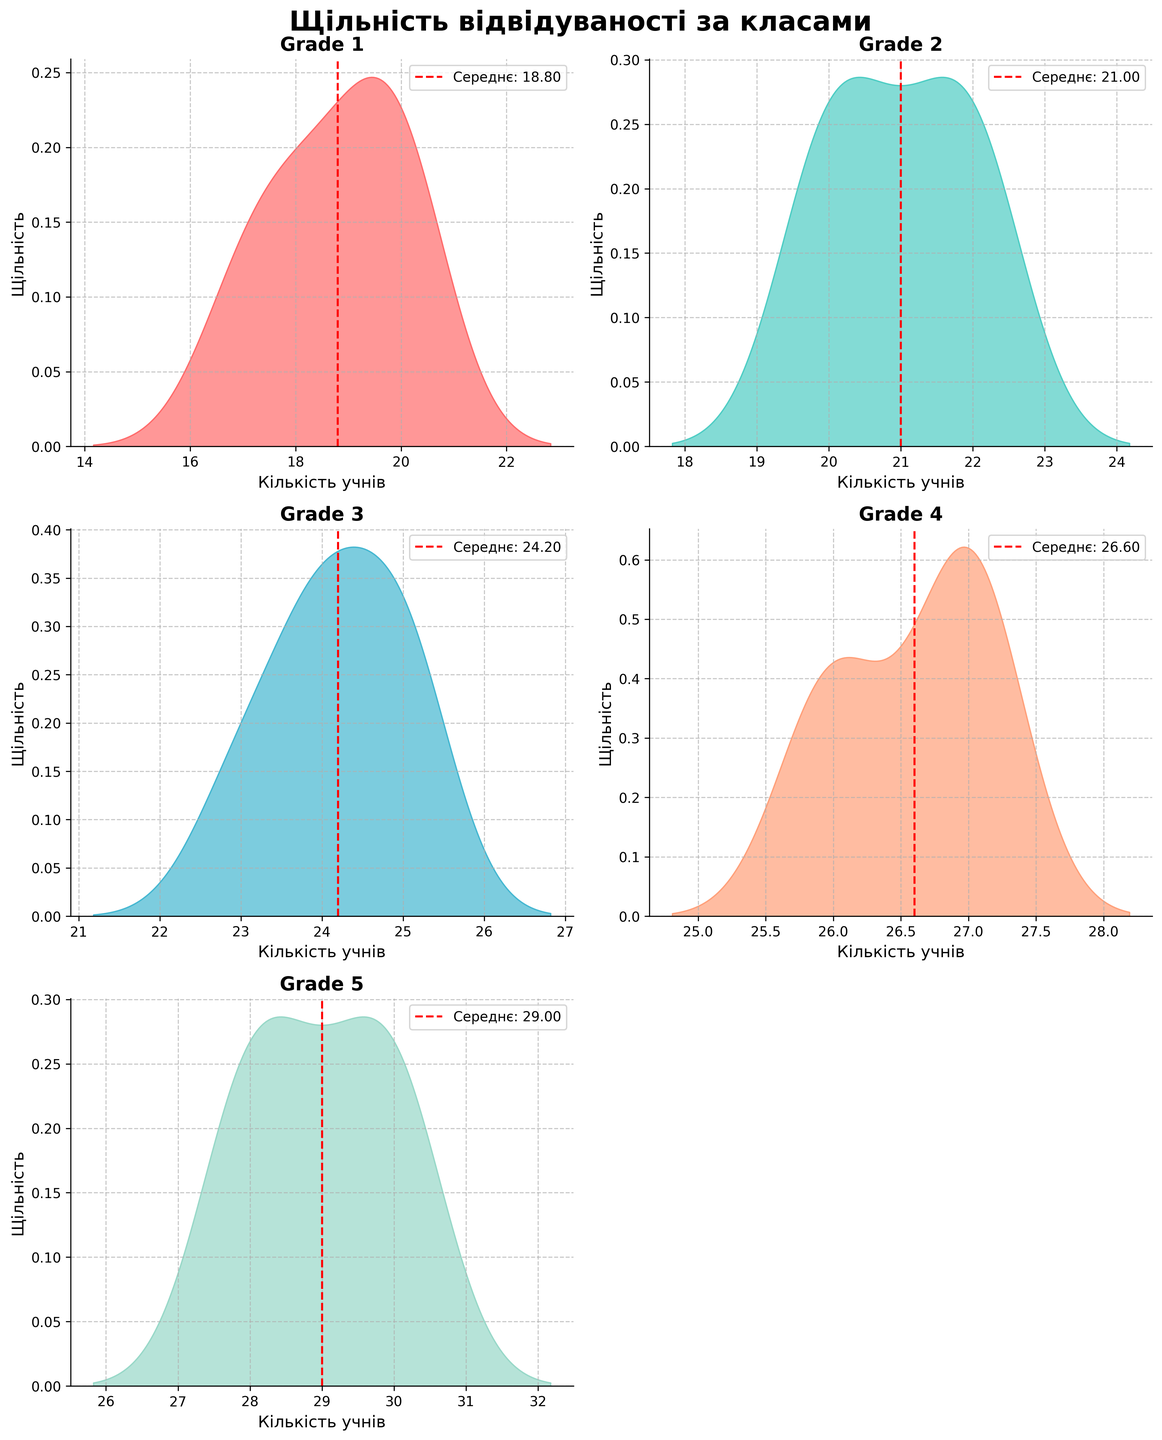What is the title of the plot? The title of the plot is usually located at the top center of the plot and summarizes what the plot is about. In this case, according to the provided code, it is written in Ukrainian.
Answer: Щільність відвідуваності за класами What is the purpose of adding a vertical red dashed line in each subplot? A vertical red dashed line is used to mark the average attendance for each grade. This provides a reference point to understand where the center of the density distribution lies.
Answer: To show average attendance Which grade has the highest average attendance according to the density plots? The average attendance is indicated by the vertical red dashed line in each subplot. The grade with the highest average attendance is the one with the red line furthest to the right. In this case, Grade 5 has the highest average attendance.
Answer: Grade 5 Which grade shows the most variation in attendance according to the density plots? Variation can be observed by looking at the spread of the density plot. A wider, flatter density plot indicates higher variation and a more spread-out attendance dataset. Grade 1 shows the most variation in attendance.
Answer: Grade 1 How does the attendance in Grade 2 compare to Grade 4 in terms of density shape? By comparing the shapes of the density plots, we can see that the densities for Grades 2 and 4 are more concentrated and have similar narrow peaks, indicating less variability.
Answer: Both have narrow peaks What does the x-axis represent in these density plots? The x-axis represents the number of students in attendance for each day. This is generally labeled at the bottom of the plot and can be inferred from the labels and context provided.
Answer: Number of students What does the y-axis represent in these density plots? The y-axis represents the density, which shows the probability of different attendance values occurring. This is usually labeled vertically along the left side of each subplot.
Answer: Density Which grades' density plots are the most similar in shape? By visually comparing the shapes of the density plots, we can see that the density plots for Grades 3 and 4 are quite similar, with both displaying narrowly peaked distributions.
Answer: Grades 3 and 4 What is the approximate range of attendance values for Grade 3? The range of attendance values for a grade can be estimated by looking at the spread of the density plot. For Grade 3, the attendance values range approximately from 23 to 25 students.
Answer: 23 to 25 students 